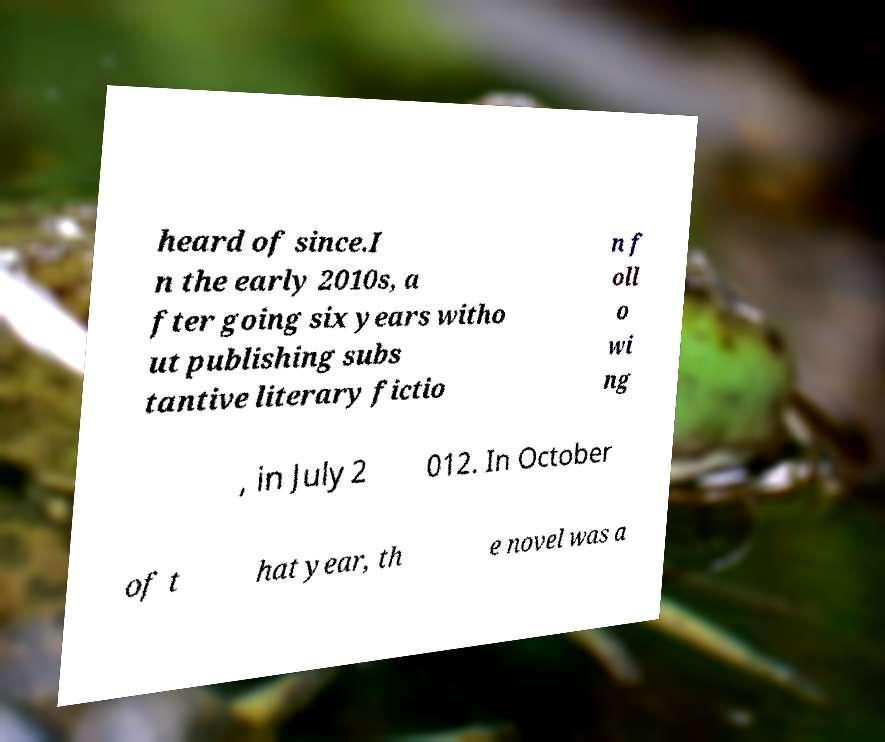There's text embedded in this image that I need extracted. Can you transcribe it verbatim? heard of since.I n the early 2010s, a fter going six years witho ut publishing subs tantive literary fictio n f oll o wi ng , in July 2 012. In October of t hat year, th e novel was a 